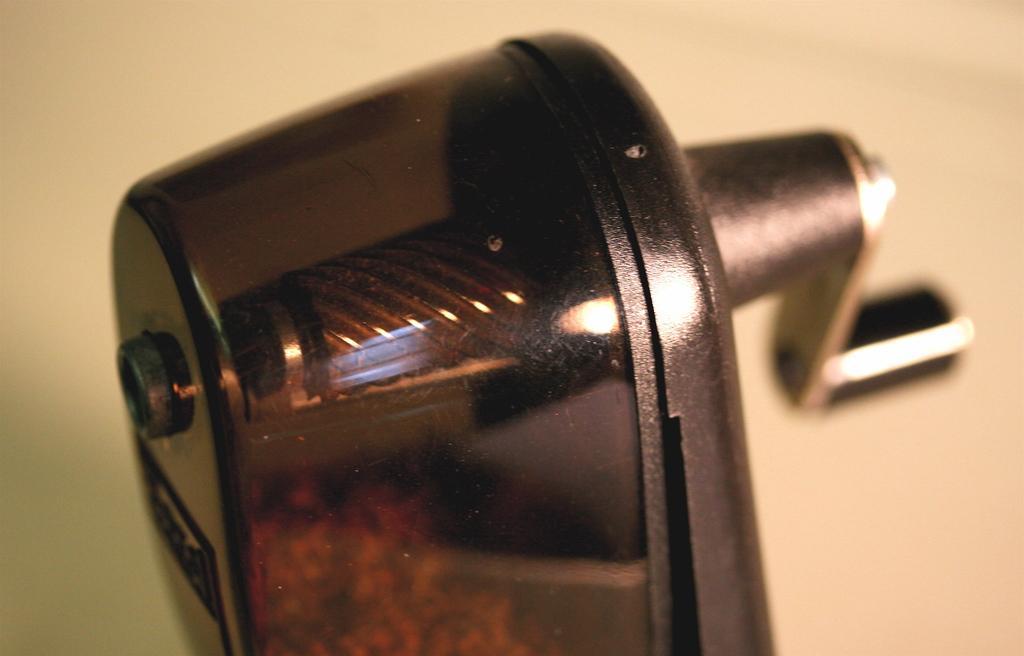Could you give a brief overview of what you see in this image? In the center of the image we can see a grater. It is in black color. In the background there is a wall. 